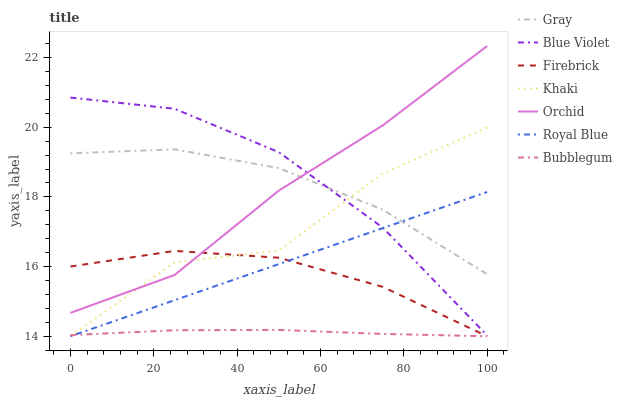Does Khaki have the minimum area under the curve?
Answer yes or no. No. Does Khaki have the maximum area under the curve?
Answer yes or no. No. Is Firebrick the smoothest?
Answer yes or no. No. Is Firebrick the roughest?
Answer yes or no. No. Does Blue Violet have the lowest value?
Answer yes or no. No. Does Khaki have the highest value?
Answer yes or no. No. Is Bubblegum less than Orchid?
Answer yes or no. Yes. Is Blue Violet greater than Bubblegum?
Answer yes or no. Yes. Does Bubblegum intersect Orchid?
Answer yes or no. No. 